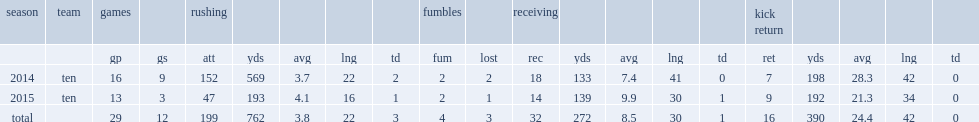How many receiving yards did sankey record in 2014? 133.0. 